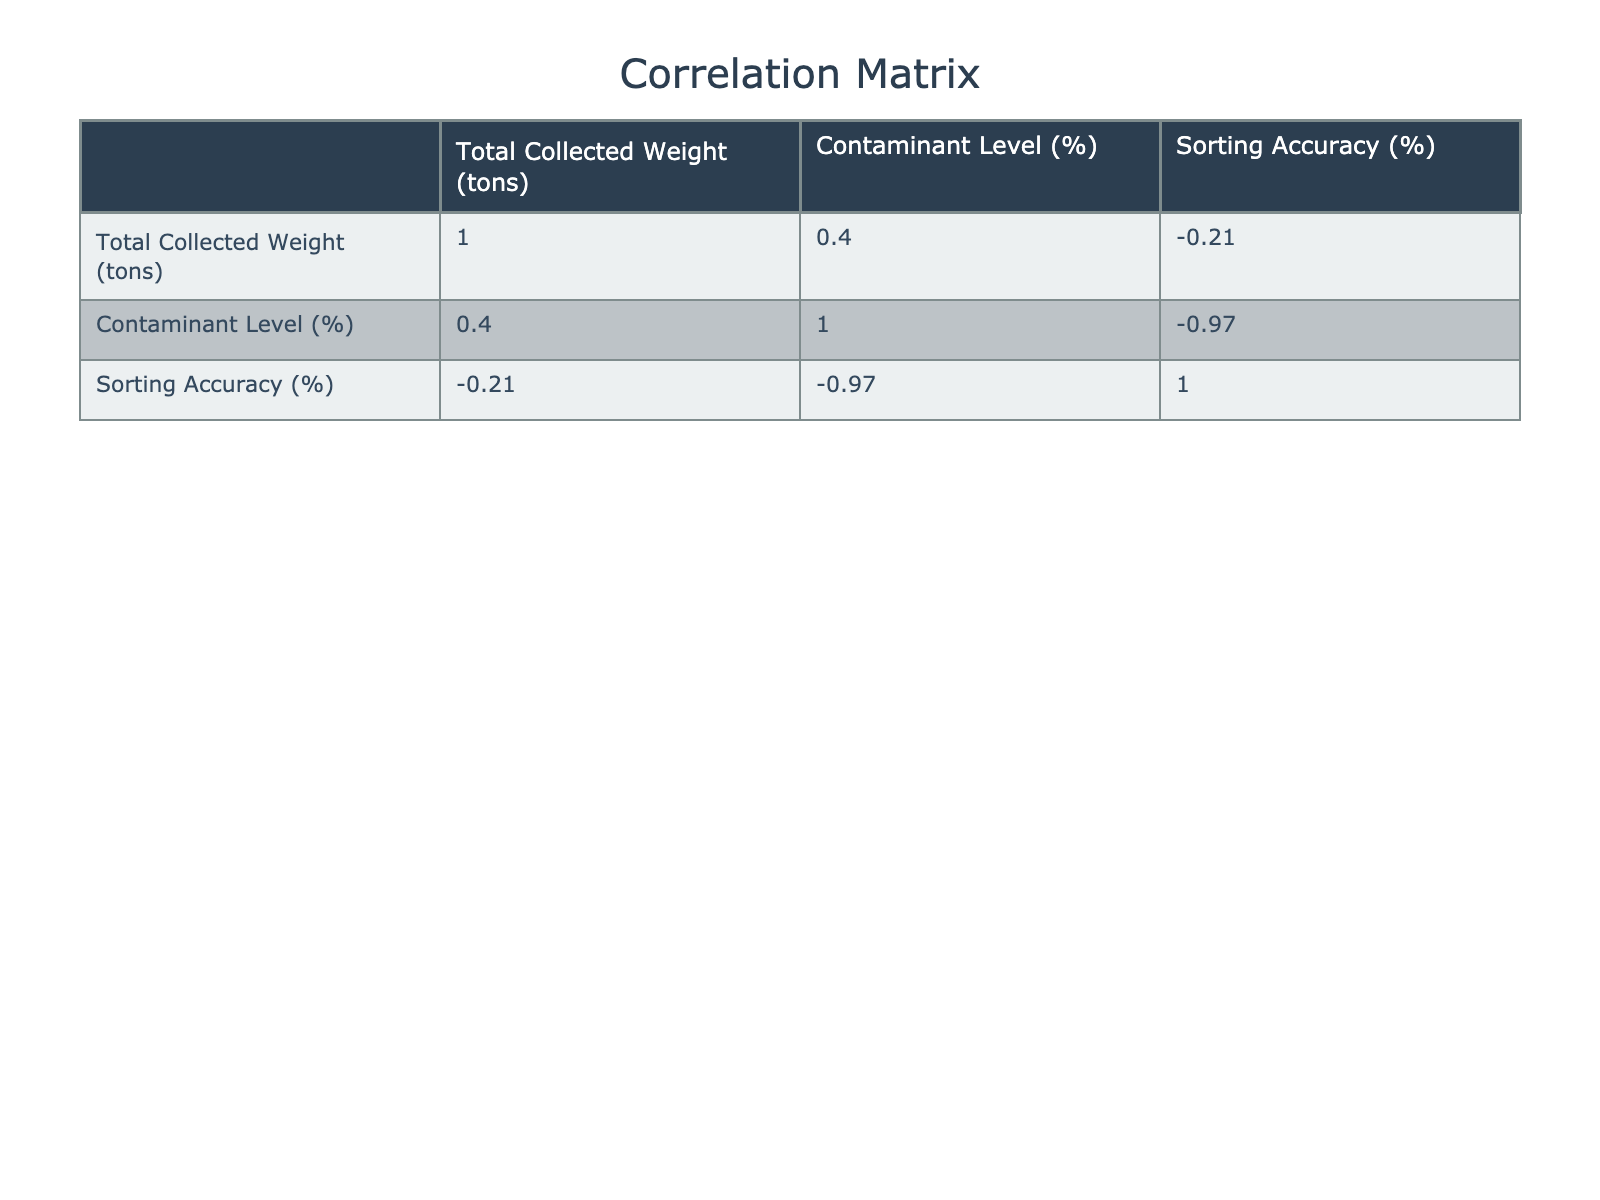What is the highest contaminant level recorded in the table? The highest contaminant level is located in the "Construction Site" row where the contaminant level is 10.3%.
Answer: 10.3% What is the sorting accuracy for the Rural Area? The sorting accuracy for the Rural Area is listed directly in the table under the corresponding row, which shows a sorting accuracy of 97%.
Answer: 97% Is there a correlation between contaminant level and sorting accuracy in the data? While the table does not explicitly state correlation values, it can be assessed that higher contaminant levels generally relate to lower sorting accuracy rates shown across various rows, suggesting a potential negative correlation.
Answer: Yes What is the average sorting accuracy for areas with a contaminant level above 5%? To find the average sorting accuracy, we first identify the areas with a contaminant level above 5%, which are the "Downtown District," "Industrial Zone," "Shopping Mall District," "Hospital Complex," and "Construction Site." The total sorting accuracy for these areas is (92 + 88 + 90 + 85 + 80) = 425. There are 5 such areas, so the average is 425/5 = 85.
Answer: 85 Which area has the lowest contaminant level, and what is its sorting accuracy? The lowest contaminant level is found in the "City Park" with a level of 1.6%. The corresponding sorting accuracy for the City Park is 98%.
Answer: City Park, 98% How do the contaminant levels of the University Campus and Residential Area compare to each other? The contaminant level for the University Campus is 4.2% whereas for the Residential Area it is 4.8%. Therefore, the Residential Area has a higher contaminant level by 0.6%.
Answer: Residential Area, higher by 0.6% What is the total weight of collected paper from areas with sorting accuracy above 90%? The areas with sorting accuracy above 90% are "Downtown District" (100 tons), "Suburban Neighborhood" (80 tons), "Rural Area" (50 tons), "University Campus" (70 tons), and "Residential Area" (110 tons). Summing these gives a total weight of 100 + 80 + 50 + 70 + 110 = 410 tons.
Answer: 410 tons Is the sorting accuracy for the Shopping Mall District better than that of the Industrial Zone? By checking the respective sorting accuracy values, the Shopping Mall District has 90% while the Industrial Zone has 88%. Therefore, the Shopping Mall District has better accuracy.
Answer: Yes What is the difference in sorting accuracy between the areas with the highest and lowest contaminant levels? The highest contaminant level is in the "Construction Site" at 10.3% with a sorting accuracy of 80%. The lowest is in the "City Park" at 1.6% with a sorting accuracy of 98%. The difference in sorting accuracy is 98% - 80% = 18%.
Answer: 18% 